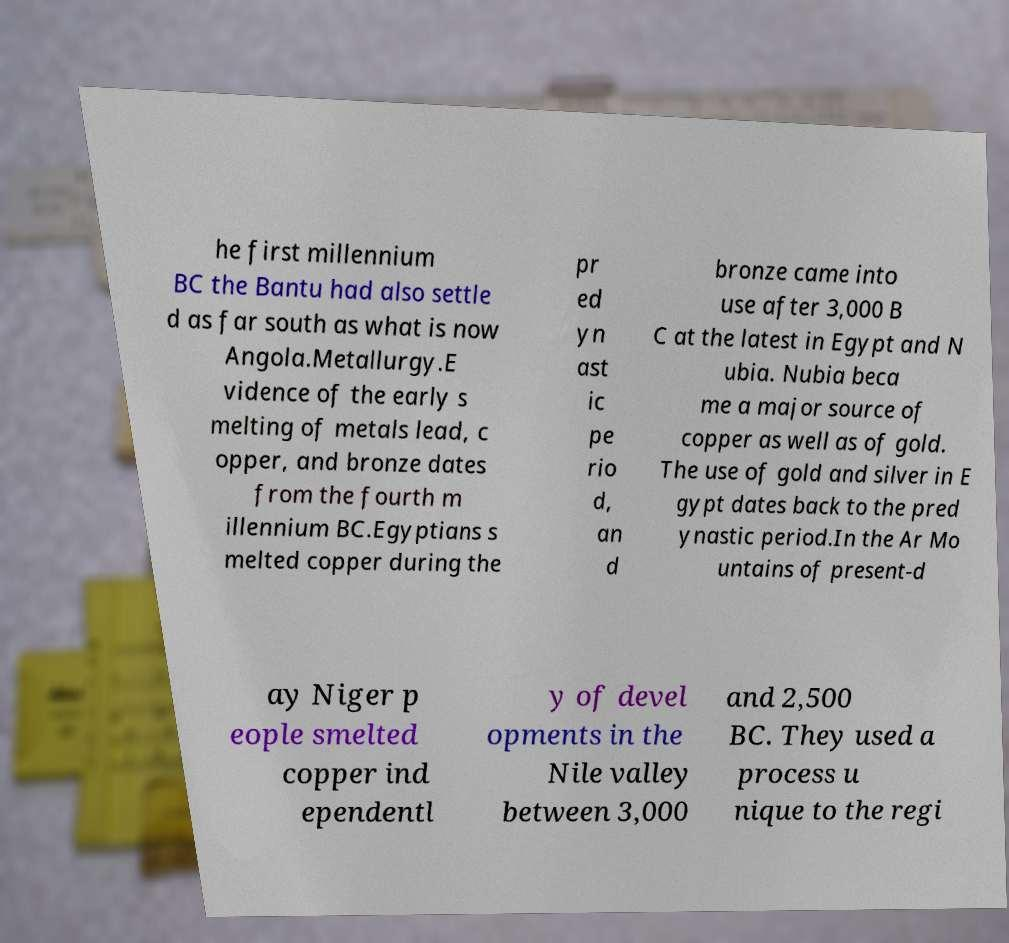I need the written content from this picture converted into text. Can you do that? he first millennium BC the Bantu had also settle d as far south as what is now Angola.Metallurgy.E vidence of the early s melting of metals lead, c opper, and bronze dates from the fourth m illennium BC.Egyptians s melted copper during the pr ed yn ast ic pe rio d, an d bronze came into use after 3,000 B C at the latest in Egypt and N ubia. Nubia beca me a major source of copper as well as of gold. The use of gold and silver in E gypt dates back to the pred ynastic period.In the Ar Mo untains of present-d ay Niger p eople smelted copper ind ependentl y of devel opments in the Nile valley between 3,000 and 2,500 BC. They used a process u nique to the regi 